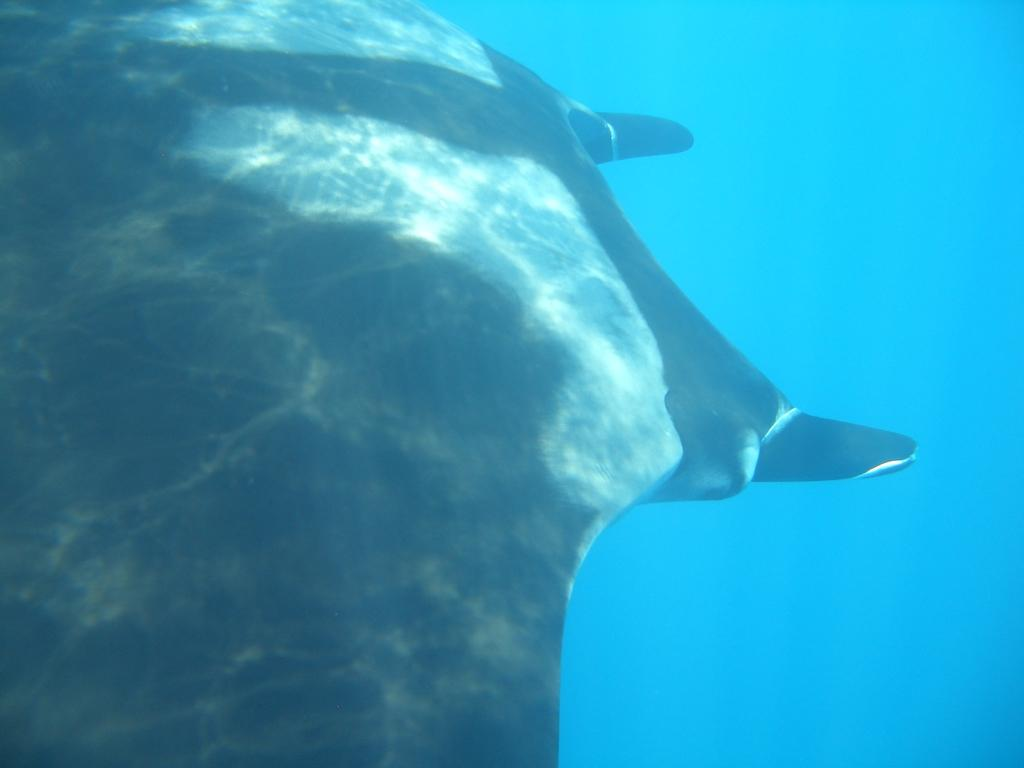What type of animal is depicted in the image? There is a picture of an aquatic animal in the image. What color is the aquatic animal? The aquatic animal is black in color. What can be seen in the background of the image? There is water visible in the background of the image. What type of nail is the stranger using to fix the tail of the aquatic animal in the image? There is no stranger, nail, or tail present in the image; it only features a picture of a black aquatic animal. 